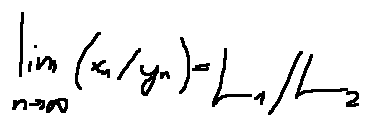Convert formula to latex. <formula><loc_0><loc_0><loc_500><loc_500>\lim \lim i t s _ { n \rightarrow \infty } ( x _ { n } / y _ { n } ) = L _ { 1 } / L _ { 2 }</formula> 